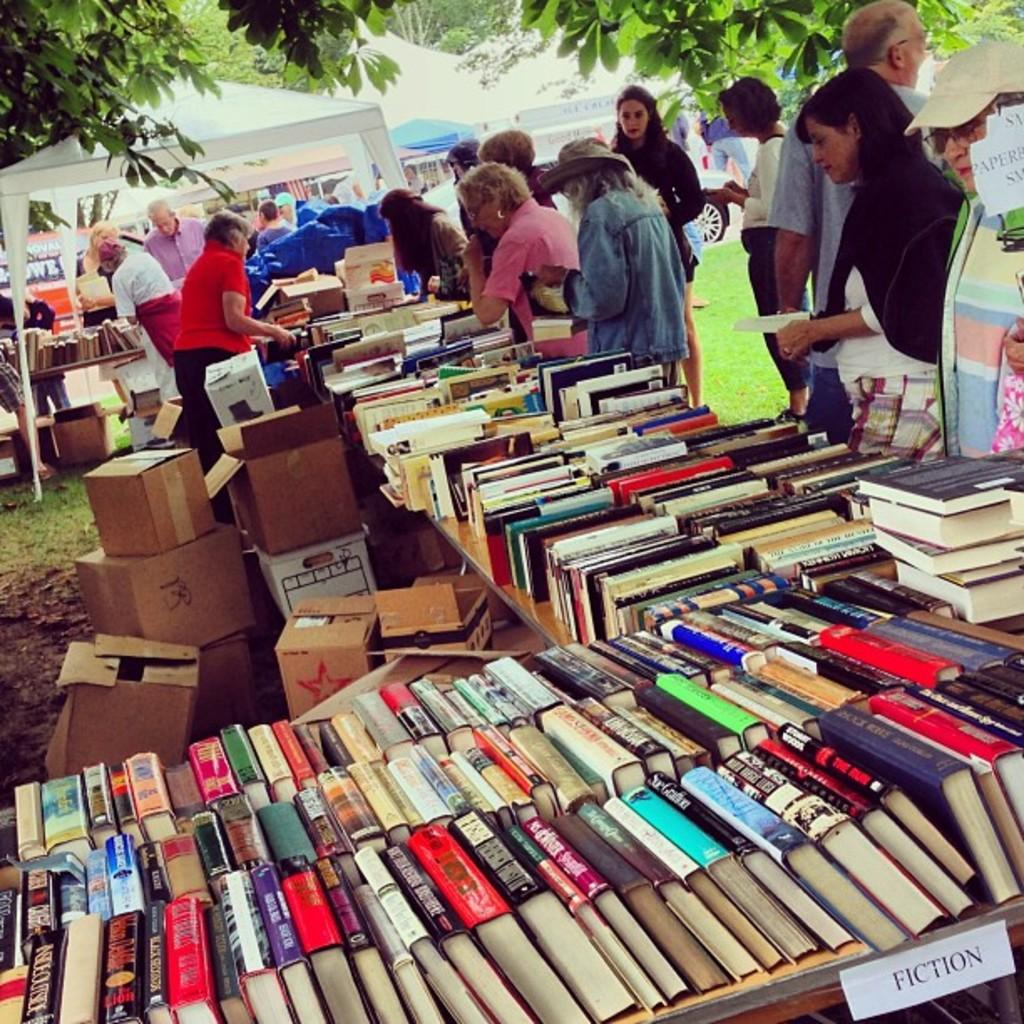<image>
Present a compact description of the photo's key features. A bunch of books on tables with people looking at them and one section is marked Fiction. 